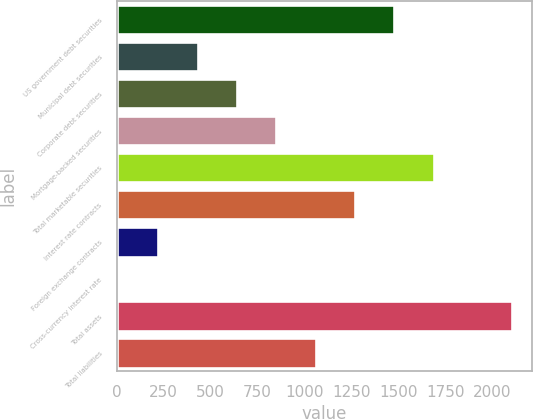Convert chart to OTSL. <chart><loc_0><loc_0><loc_500><loc_500><bar_chart><fcel>US government debt securities<fcel>Municipal debt securities<fcel>Corporate debt securities<fcel>Mortgage-backed securities<fcel>Total marketable securities<fcel>Interest rate contracts<fcel>Foreign exchange contracts<fcel>Cross-currency interest rate<fcel>Total assets<fcel>Total liabilities<nl><fcel>1478.2<fcel>430.2<fcel>639.8<fcel>849.4<fcel>1687.8<fcel>1268.6<fcel>220.6<fcel>11<fcel>2107<fcel>1059<nl></chart> 